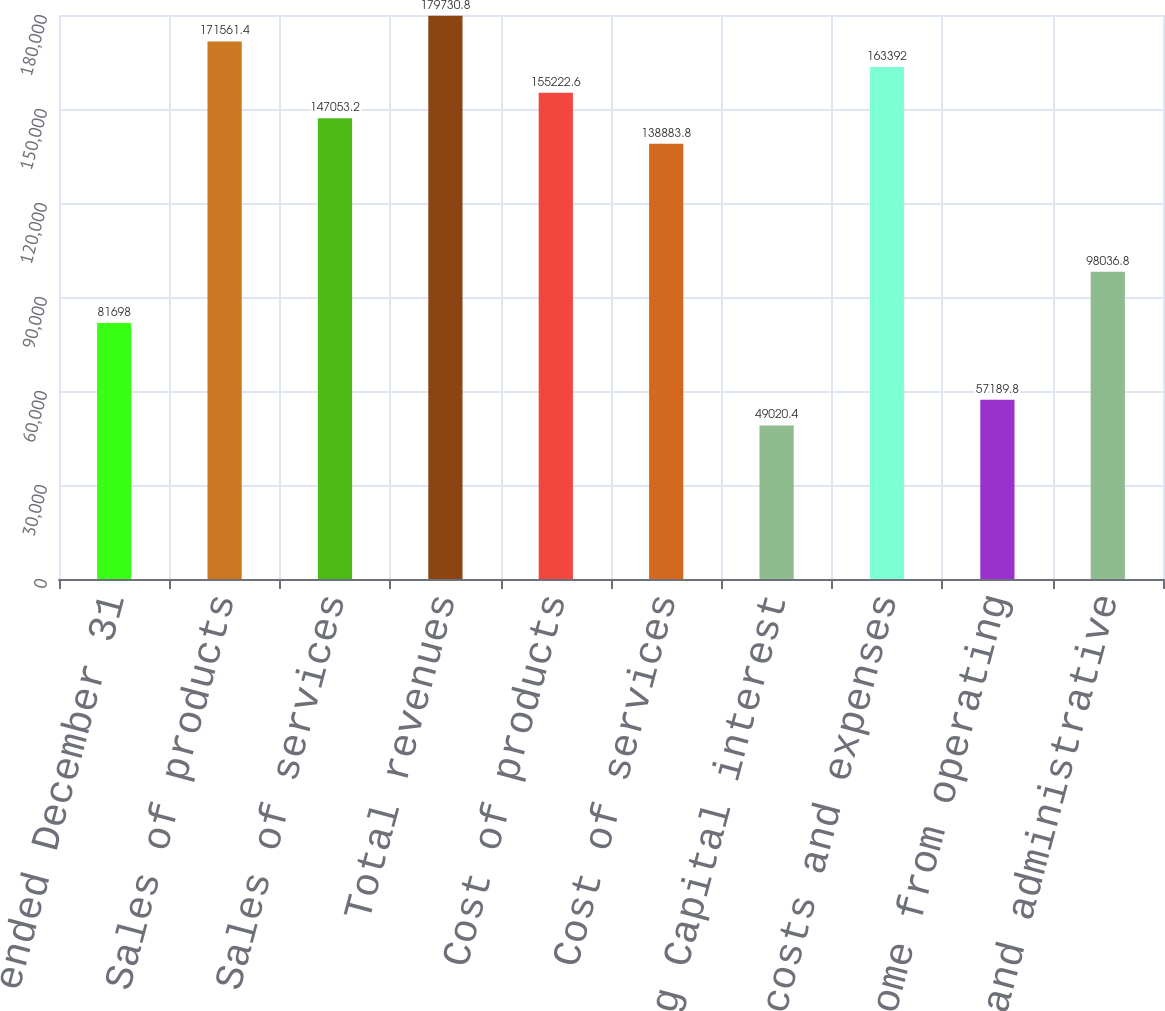Convert chart. <chart><loc_0><loc_0><loc_500><loc_500><bar_chart><fcel>Years ended December 31<fcel>Sales of products<fcel>Sales of services<fcel>Total revenues<fcel>Cost of products<fcel>Cost of services<fcel>Boeing Capital interest<fcel>Total costs and expenses<fcel>Income from operating<fcel>General and administrative<nl><fcel>81698<fcel>171561<fcel>147053<fcel>179731<fcel>155223<fcel>138884<fcel>49020.4<fcel>163392<fcel>57189.8<fcel>98036.8<nl></chart> 